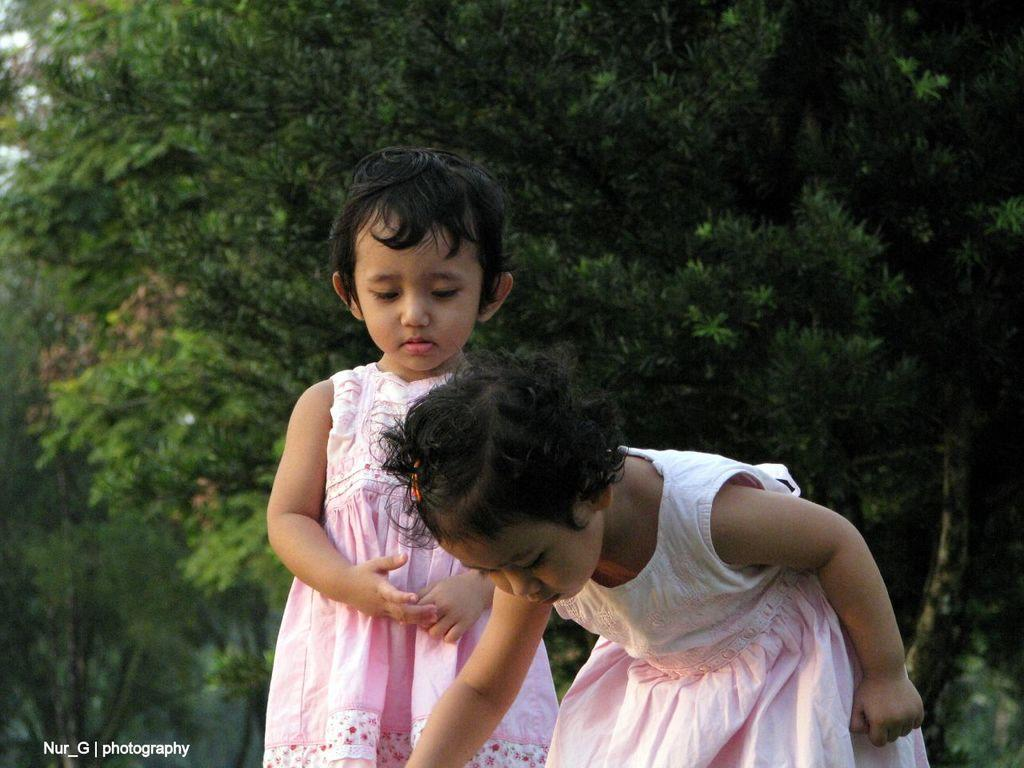How many people are in the image? There are two girls in the middle of the image. What is present in the bottom left-hand side of the image? There is a watermark in the bottom left-hand side of the image. What can be seen in the background of the image? There are trees in the background of the image. Can you see any flames in the image? No, there are no flames present in the image. Are there any goldfish swimming in the watermark? No, there are no goldfish in the image, and the watermark is not a body of water where fish could swim. 